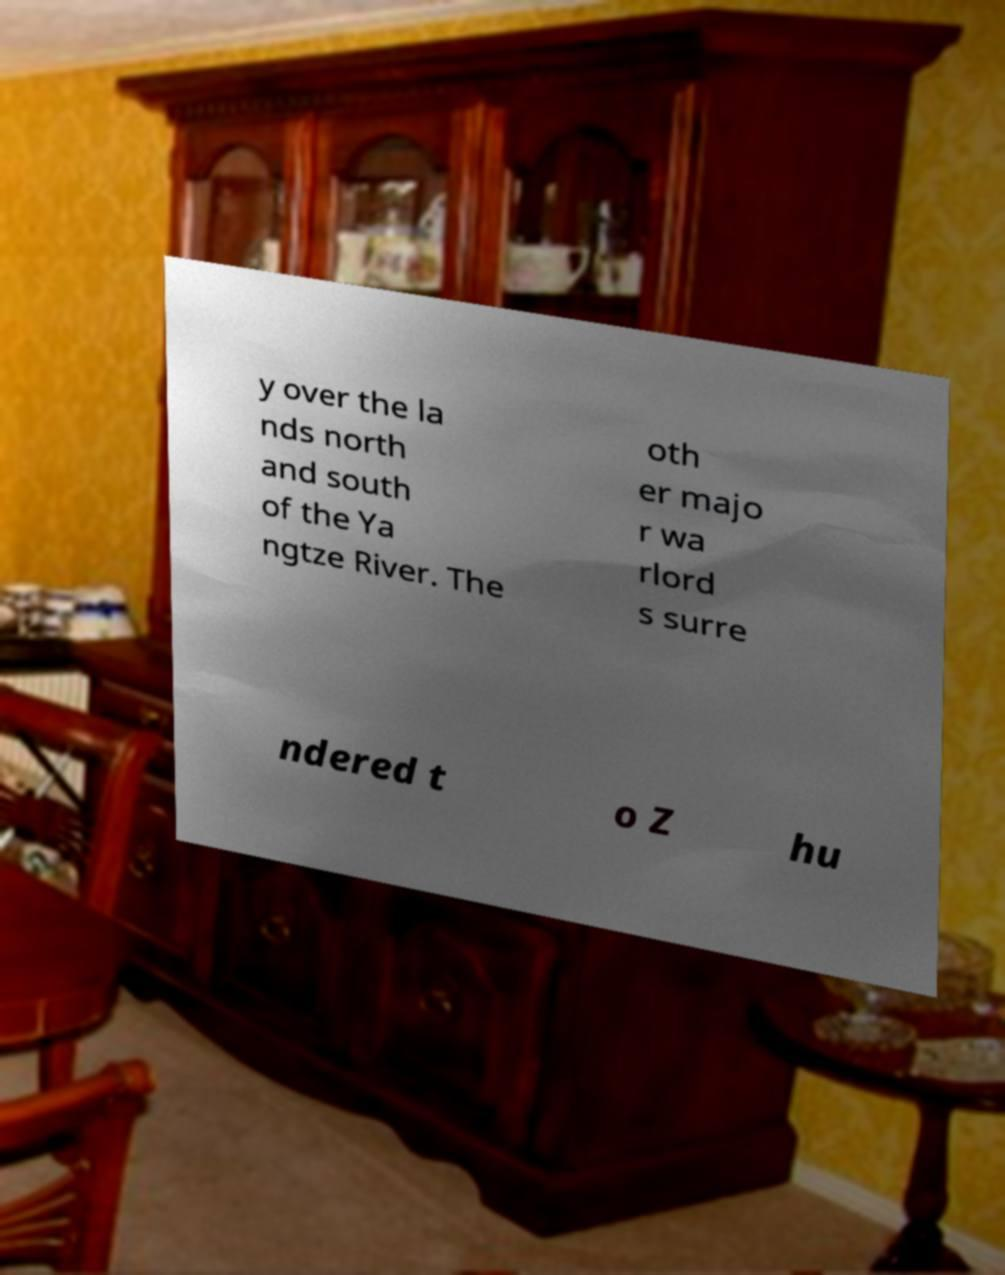For documentation purposes, I need the text within this image transcribed. Could you provide that? y over the la nds north and south of the Ya ngtze River. The oth er majo r wa rlord s surre ndered t o Z hu 